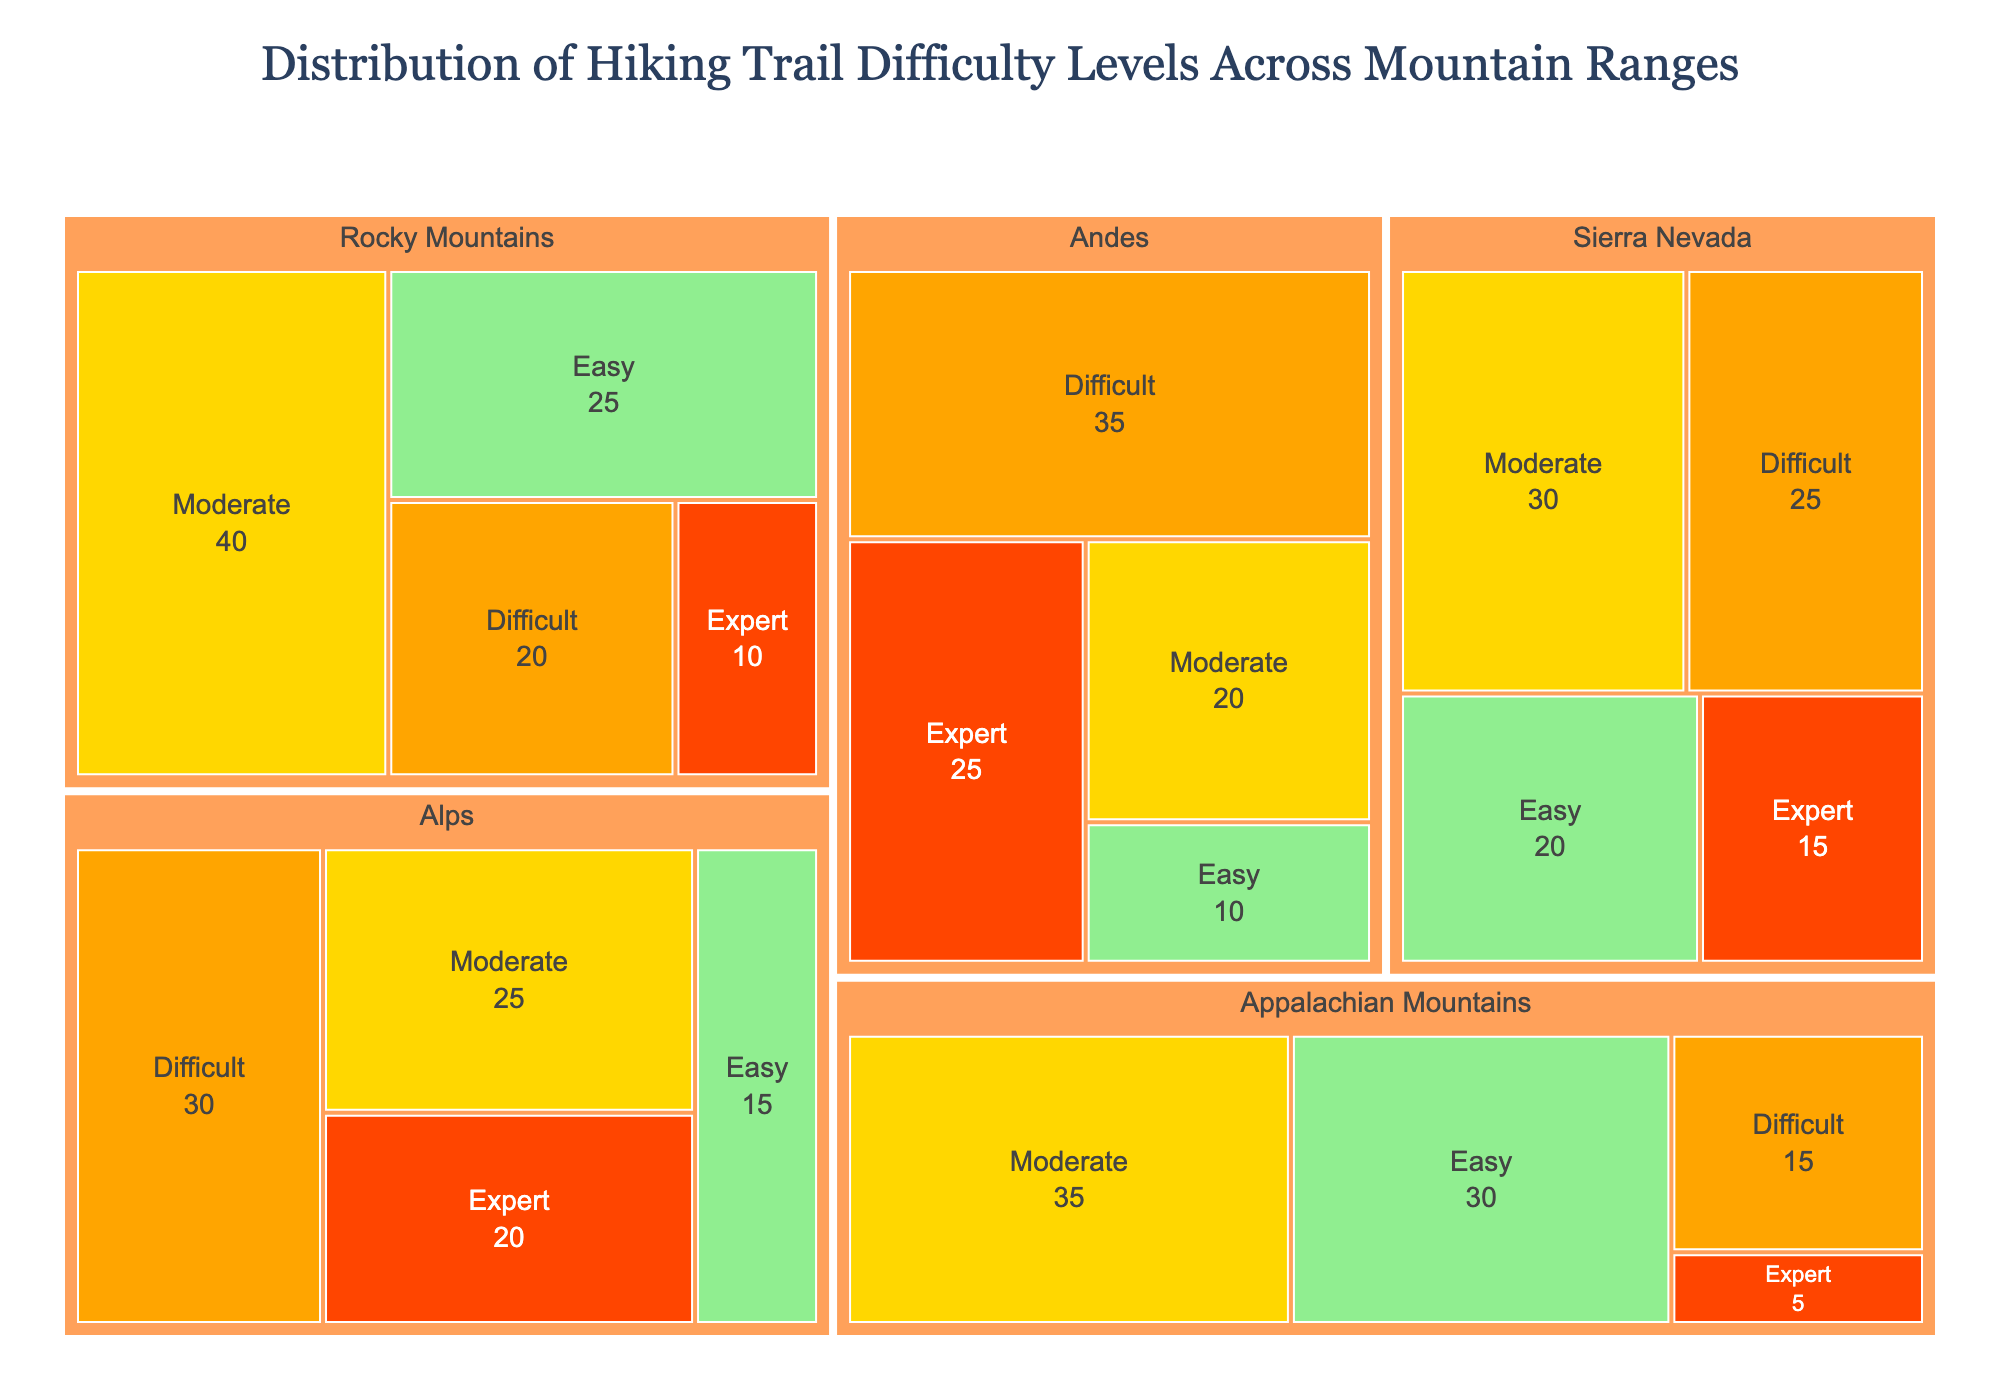What is the title of the treemap? The title of the treemap is typically displayed at the top of the figure. By looking at the top, you can see that the title is 'Distribution of Hiking Trail Difficulty Levels Across Mountain Ranges'.
Answer: Distribution of Hiking Trail Difficulty Levels Across Mountain Ranges Which mountain range has the highest number of expert trails? To find the mountain range with the highest number of expert trails, locate all the 'Expert' difficulty levels and compare the numbers. The Andes have 25 expert trails, which is the highest.
Answer: Andes How many easy trails are there in total across all mountain ranges? To determine the total number of easy trails, sum the easy trails from all mountain ranges: Rocky Mountains (25), Appalachian Mountains (30), Sierra Nevada (20), Alps (15), and Andes (10). Therefore, 25 + 30 + 20 + 15 + 10 equals 100.
Answer: 100 Compare the number of moderate trails in the Rocky Mountains with those in the Sierra Nevada. Which has more? Locate the 'Moderate' trails for both the Rocky Mountains (40) and Sierra Nevada (30). Since 40 is greater than 30, the Rocky Mountains have more moderate trails.
Answer: Rocky Mountains What percentage of trails in the Alps are difficult trails? First, identify the number of difficult trails in the Alps, which is 30. Then, calculate the total number of trails in the Alps: Easy (15) + Moderate (25) + Difficult (30) + Expert (20) = 90. The percentage is (30/90) * 100%.
Answer: 33% Which mountain range has the fewest trails overall, and how many does it have? Calculate the total number of trails for each mountain range and compare: Rocky Mountains (25 + 40 + 20 + 10 = 95), Appalachian Mountains (30 + 35 + 15 + 5 = 85), Sierra Nevada (20 + 30 + 25 + 15 = 90), Alps (15 + 25 + 30 + 20 = 90), Andes (10 + 20 + 35 + 25 = 90). The Appalachian Mountains have the fewest with 85 trails.
Answer: Appalachian Mountains, 85 How many mountain ranges have more than 20 expert trails? Look at the number of expert trails for each mountain range. The Andes (25) and the Alps (20) have more than 20 expert trails. So, the answer is 1 range (Alps has exactly 20, not more than 20).
Answer: 1 Is the total number of difficult trails greater in the Rocky Mountains or the Andes? Check the number of difficult trails in Rocky Mountains (20) and Andes (35). Since 35 is greater than 20, the Andes have more difficult trails.
Answer: Andes What is the color representation for difficult trails in the treemap? By noting the color legend provided in the treemap, difficult trails are represented by the color orange.
Answer: Orange 